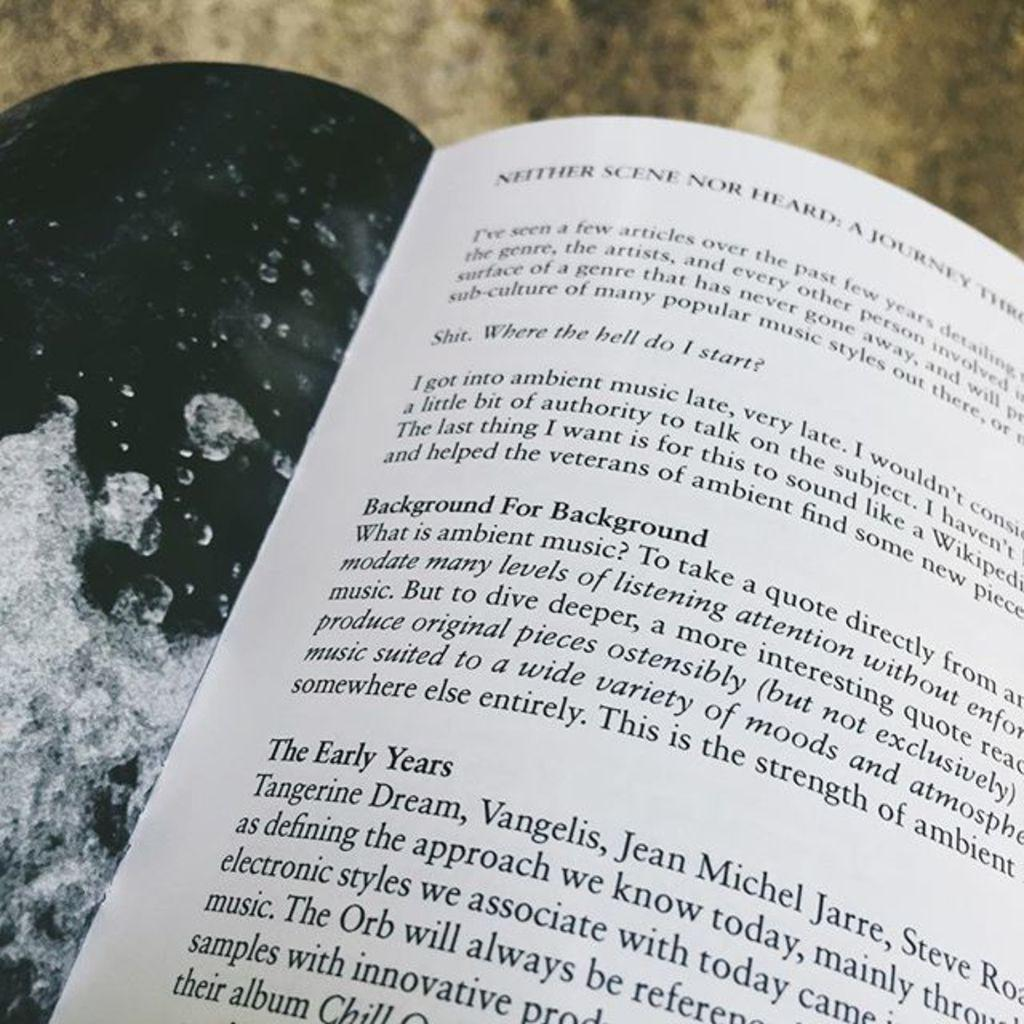<image>
Summarize the visual content of the image. a book with the words 'background for background' typed out in bold 